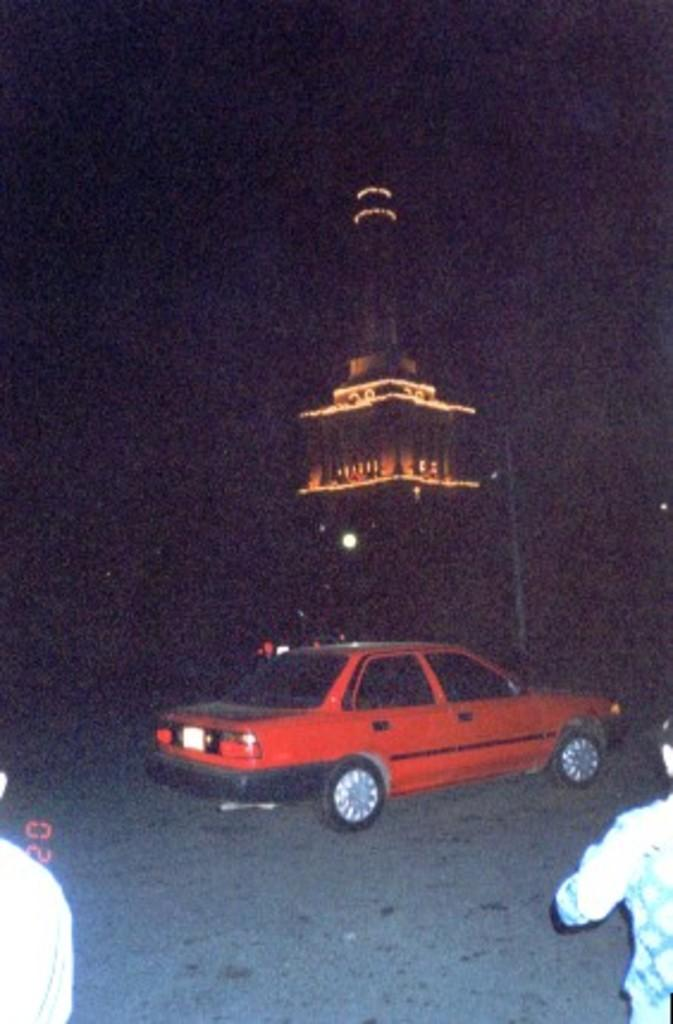What is the main subject of the image? The main subject of the image is a car on the road. What can be seen in the background of the image? There is a statue in the background of the image. What feature does the statue have? The statue has lights. How many people are visible in the image? There are two persons, one on each side of the image. What type of instrument is being played by the person on the left side of the image? There is no instrument present in the image; the person on the left side of the image is not holding or playing any instrument. 